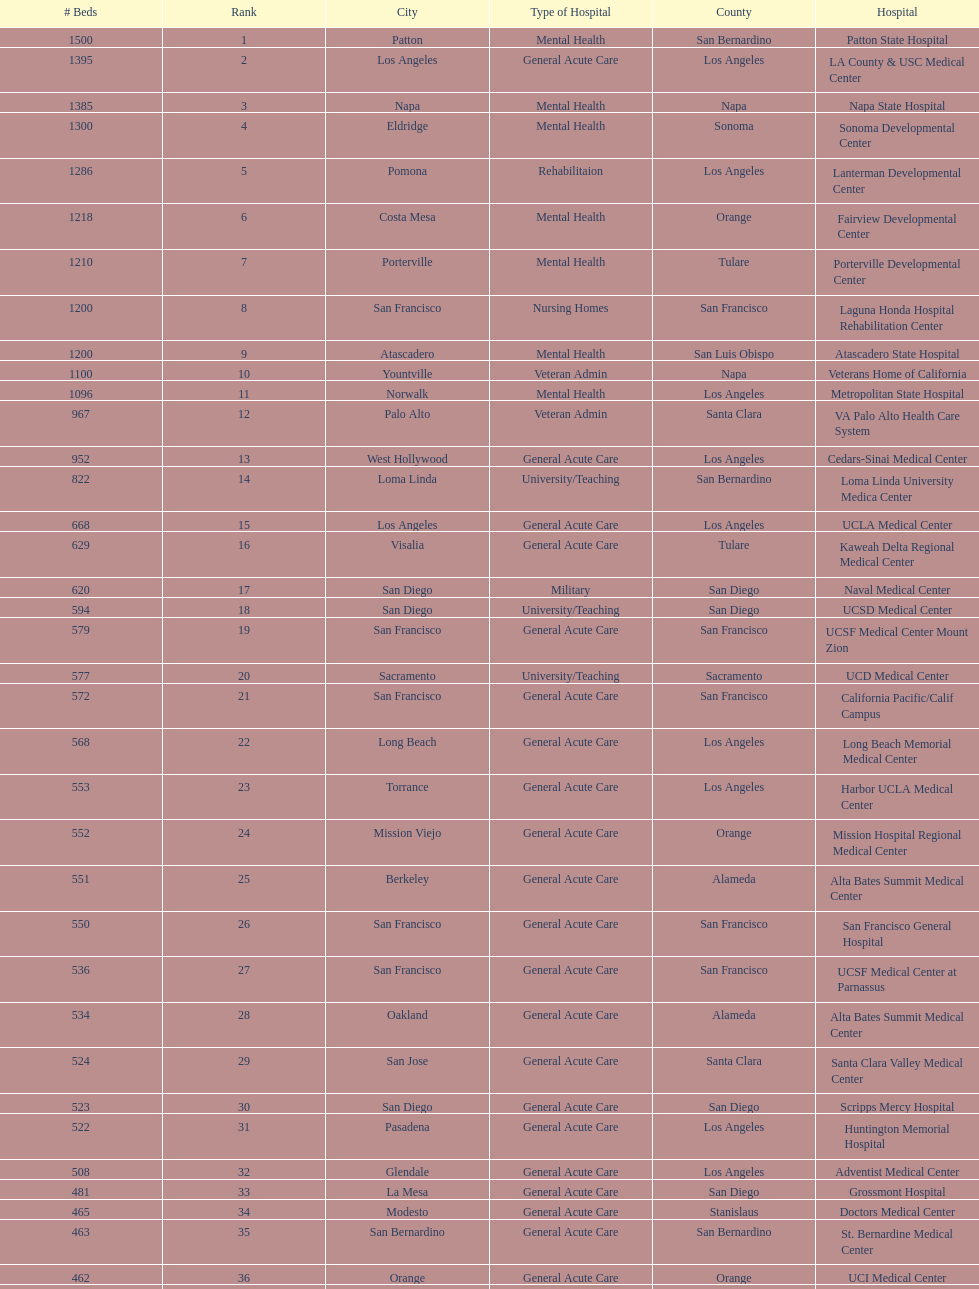Parse the full table. {'header': ['# Beds', 'Rank', 'City', 'Type of Hospital', 'County', 'Hospital'], 'rows': [['1500', '1', 'Patton', 'Mental Health', 'San Bernardino', 'Patton State Hospital'], ['1395', '2', 'Los Angeles', 'General Acute Care', 'Los Angeles', 'LA County & USC Medical Center'], ['1385', '3', 'Napa', 'Mental Health', 'Napa', 'Napa State Hospital'], ['1300', '4', 'Eldridge', 'Mental Health', 'Sonoma', 'Sonoma Developmental Center'], ['1286', '5', 'Pomona', 'Rehabilitaion', 'Los Angeles', 'Lanterman Developmental Center'], ['1218', '6', 'Costa Mesa', 'Mental Health', 'Orange', 'Fairview Developmental Center'], ['1210', '7', 'Porterville', 'Mental Health', 'Tulare', 'Porterville Developmental Center'], ['1200', '8', 'San Francisco', 'Nursing Homes', 'San Francisco', 'Laguna Honda Hospital Rehabilitation Center'], ['1200', '9', 'Atascadero', 'Mental Health', 'San Luis Obispo', 'Atascadero State Hospital'], ['1100', '10', 'Yountville', 'Veteran Admin', 'Napa', 'Veterans Home of California'], ['1096', '11', 'Norwalk', 'Mental Health', 'Los Angeles', 'Metropolitan State Hospital'], ['967', '12', 'Palo Alto', 'Veteran Admin', 'Santa Clara', 'VA Palo Alto Health Care System'], ['952', '13', 'West Hollywood', 'General Acute Care', 'Los Angeles', 'Cedars-Sinai Medical Center'], ['822', '14', 'Loma Linda', 'University/Teaching', 'San Bernardino', 'Loma Linda University Medica Center'], ['668', '15', 'Los Angeles', 'General Acute Care', 'Los Angeles', 'UCLA Medical Center'], ['629', '16', 'Visalia', 'General Acute Care', 'Tulare', 'Kaweah Delta Regional Medical Center'], ['620', '17', 'San Diego', 'Military', 'San Diego', 'Naval Medical Center'], ['594', '18', 'San Diego', 'University/Teaching', 'San Diego', 'UCSD Medical Center'], ['579', '19', 'San Francisco', 'General Acute Care', 'San Francisco', 'UCSF Medical Center Mount Zion'], ['577', '20', 'Sacramento', 'University/Teaching', 'Sacramento', 'UCD Medical Center'], ['572', '21', 'San Francisco', 'General Acute Care', 'San Francisco', 'California Pacific/Calif Campus'], ['568', '22', 'Long Beach', 'General Acute Care', 'Los Angeles', 'Long Beach Memorial Medical Center'], ['553', '23', 'Torrance', 'General Acute Care', 'Los Angeles', 'Harbor UCLA Medical Center'], ['552', '24', 'Mission Viejo', 'General Acute Care', 'Orange', 'Mission Hospital Regional Medical Center'], ['551', '25', 'Berkeley', 'General Acute Care', 'Alameda', 'Alta Bates Summit Medical Center'], ['550', '26', 'San Francisco', 'General Acute Care', 'San Francisco', 'San Francisco General Hospital'], ['536', '27', 'San Francisco', 'General Acute Care', 'San Francisco', 'UCSF Medical Center at Parnassus'], ['534', '28', 'Oakland', 'General Acute Care', 'Alameda', 'Alta Bates Summit Medical Center'], ['524', '29', 'San Jose', 'General Acute Care', 'Santa Clara', 'Santa Clara Valley Medical Center'], ['523', '30', 'San Diego', 'General Acute Care', 'San Diego', 'Scripps Mercy Hospital'], ['522', '31', 'Pasadena', 'General Acute Care', 'Los Angeles', 'Huntington Memorial Hospital'], ['508', '32', 'Glendale', 'General Acute Care', 'Los Angeles', 'Adventist Medical Center'], ['481', '33', 'La Mesa', 'General Acute Care', 'San Diego', 'Grossmont Hospital'], ['465', '34', 'Modesto', 'General Acute Care', 'Stanislaus', 'Doctors Medical Center'], ['463', '35', 'San Bernardino', 'General Acute Care', 'San Bernardino', 'St. Bernardine Medical Center'], ['462', '36', 'Orange', 'General Acute Care', 'Orange', 'UCI Medical Center'], ['460', '37', 'Stanford', 'General Acute Care', 'Santa Clara', 'Stanford Medical Center'], ['457', '38', 'Fresno', 'General Acute Care', 'Fresno', 'Community Regional Medical Center'], ['455', '39', 'Arcadia', 'General Acute Care', 'Los Angeles', 'Methodist Hospital'], ['455', '40', 'Burbank', 'General Acute Care', 'Los Angeles', 'Providence St. Joseph Medical Center'], ['450', '41', 'Newport Beach', 'General Acute Care', 'Orange', 'Hoag Memorial Hospital'], ['450', '42', 'San Jose', 'Mental Health', 'Santa Clara', 'Agnews Developmental Center'], ['450', '43', 'San Francisco', 'Nursing Homes', 'San Francisco', 'Jewish Home'], ['448', '44', 'Orange', 'General Acute Care', 'Orange', 'St. Joseph Hospital Orange'], ['441', '45', 'Whittier', 'General Acute Care', 'Los Angeles', 'Presbyterian Intercommunity'], ['440', '46', 'Fontana', 'General Acute Care', 'San Bernardino', 'Kaiser Permanente Medical Center'], ['439', '47', 'Los Angeles', 'General Acute Care', 'Los Angeles', 'Kaiser Permanente Medical Center'], ['436', '48', 'Pomona', 'General Acute Care', 'Los Angeles', 'Pomona Valley Hospital Medical Center'], ['432', '49', 'Sacramento', 'General Acute Care', 'Sacramento', 'Sutter General Medical Center'], ['430', '50', 'San Francisco', 'General Acute Care', 'San Francisco', 'St. Mary Medical Center'], ['429', '50', 'San Jose', 'General Acute Care', 'Santa Clara', 'Good Samaritan Hospital']]} How many more general acute care hospitals are there in california than rehabilitation hospitals? 33. 